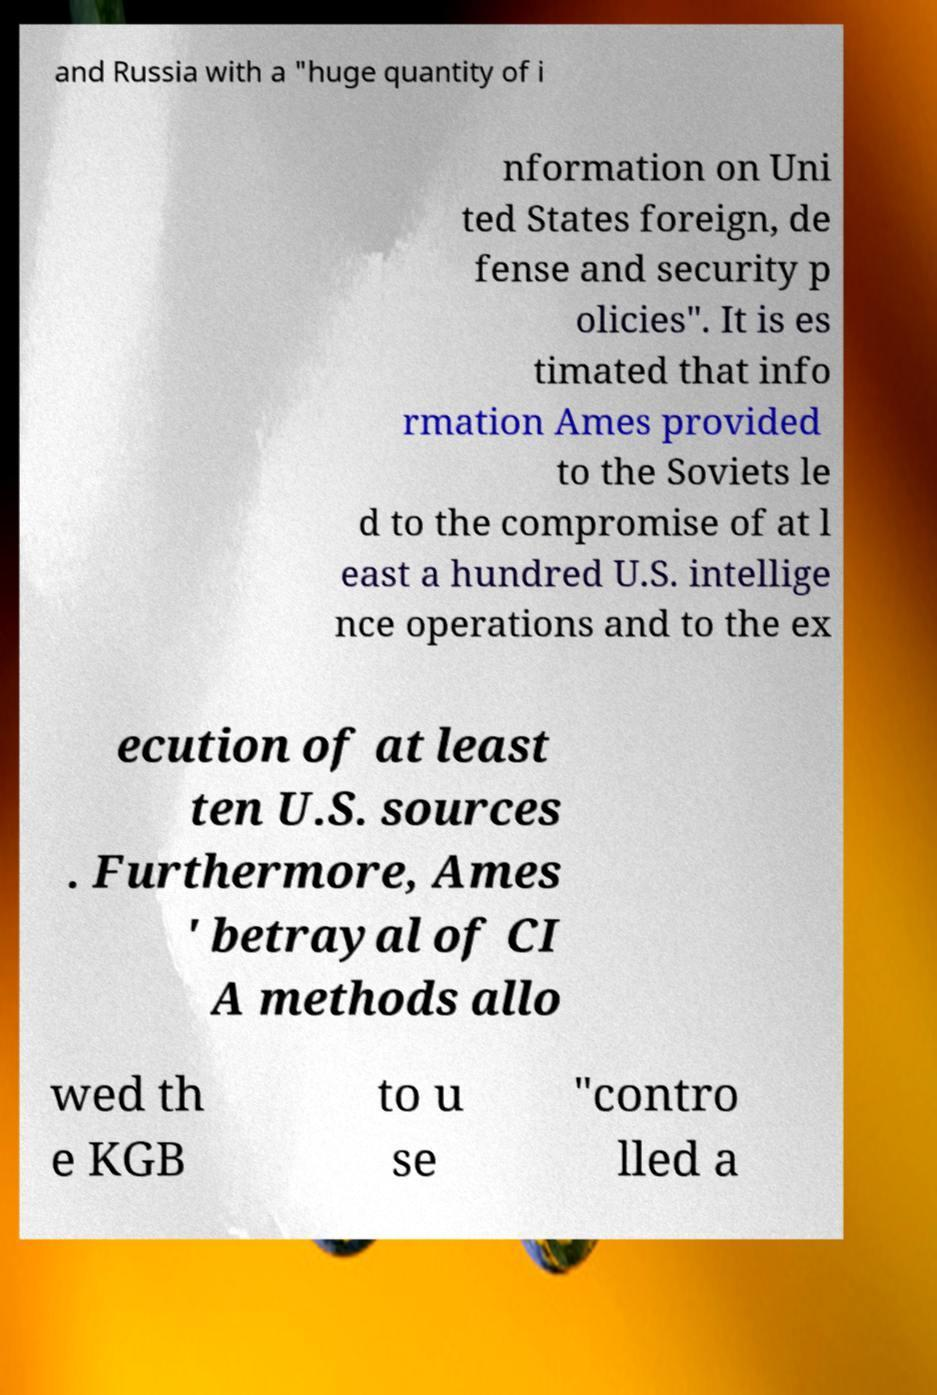Please identify and transcribe the text found in this image. and Russia with a "huge quantity of i nformation on Uni ted States foreign, de fense and security p olicies". It is es timated that info rmation Ames provided to the Soviets le d to the compromise of at l east a hundred U.S. intellige nce operations and to the ex ecution of at least ten U.S. sources . Furthermore, Ames ' betrayal of CI A methods allo wed th e KGB to u se "contro lled a 